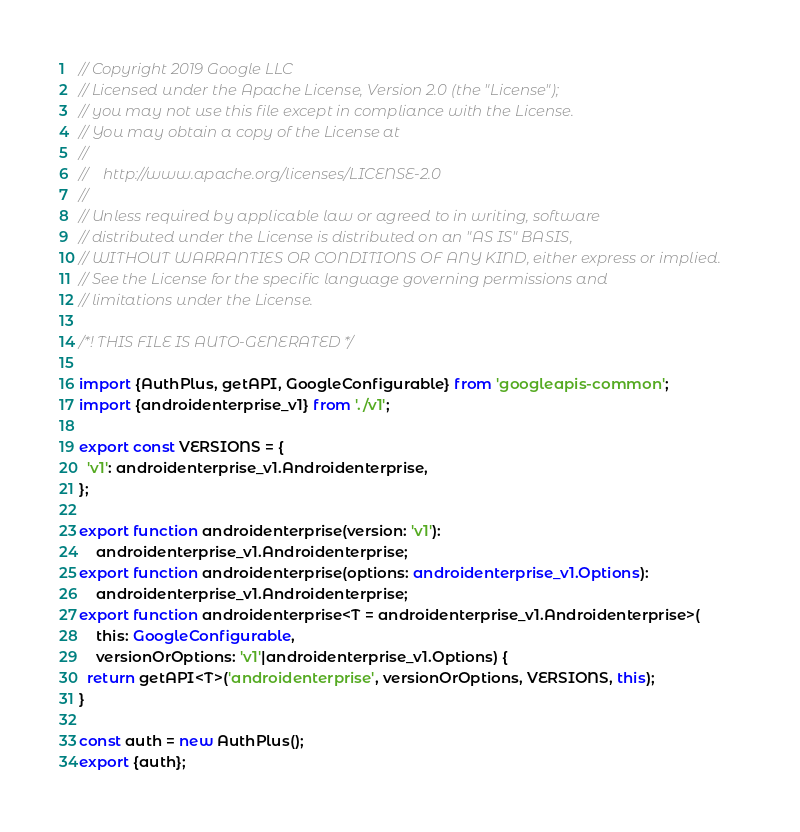Convert code to text. <code><loc_0><loc_0><loc_500><loc_500><_TypeScript_>// Copyright 2019 Google LLC
// Licensed under the Apache License, Version 2.0 (the "License");
// you may not use this file except in compliance with the License.
// You may obtain a copy of the License at
//
//    http://www.apache.org/licenses/LICENSE-2.0
//
// Unless required by applicable law or agreed to in writing, software
// distributed under the License is distributed on an "AS IS" BASIS,
// WITHOUT WARRANTIES OR CONDITIONS OF ANY KIND, either express or implied.
// See the License for the specific language governing permissions and
// limitations under the License.

/*! THIS FILE IS AUTO-GENERATED */

import {AuthPlus, getAPI, GoogleConfigurable} from 'googleapis-common';
import {androidenterprise_v1} from './v1';

export const VERSIONS = {
  'v1': androidenterprise_v1.Androidenterprise,
};

export function androidenterprise(version: 'v1'):
    androidenterprise_v1.Androidenterprise;
export function androidenterprise(options: androidenterprise_v1.Options):
    androidenterprise_v1.Androidenterprise;
export function androidenterprise<T = androidenterprise_v1.Androidenterprise>(
    this: GoogleConfigurable,
    versionOrOptions: 'v1'|androidenterprise_v1.Options) {
  return getAPI<T>('androidenterprise', versionOrOptions, VERSIONS, this);
}

const auth = new AuthPlus();
export {auth};
</code> 